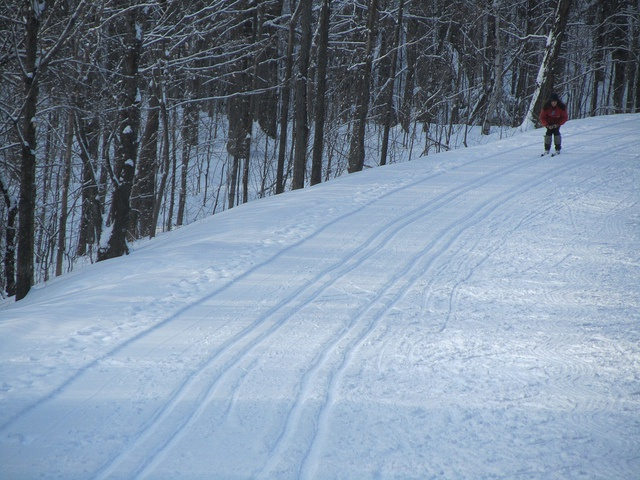Describe the objects in this image and their specific colors. I can see people in purple, black, maroon, and gray tones and skis in purple, gray, and darkgray tones in this image. 